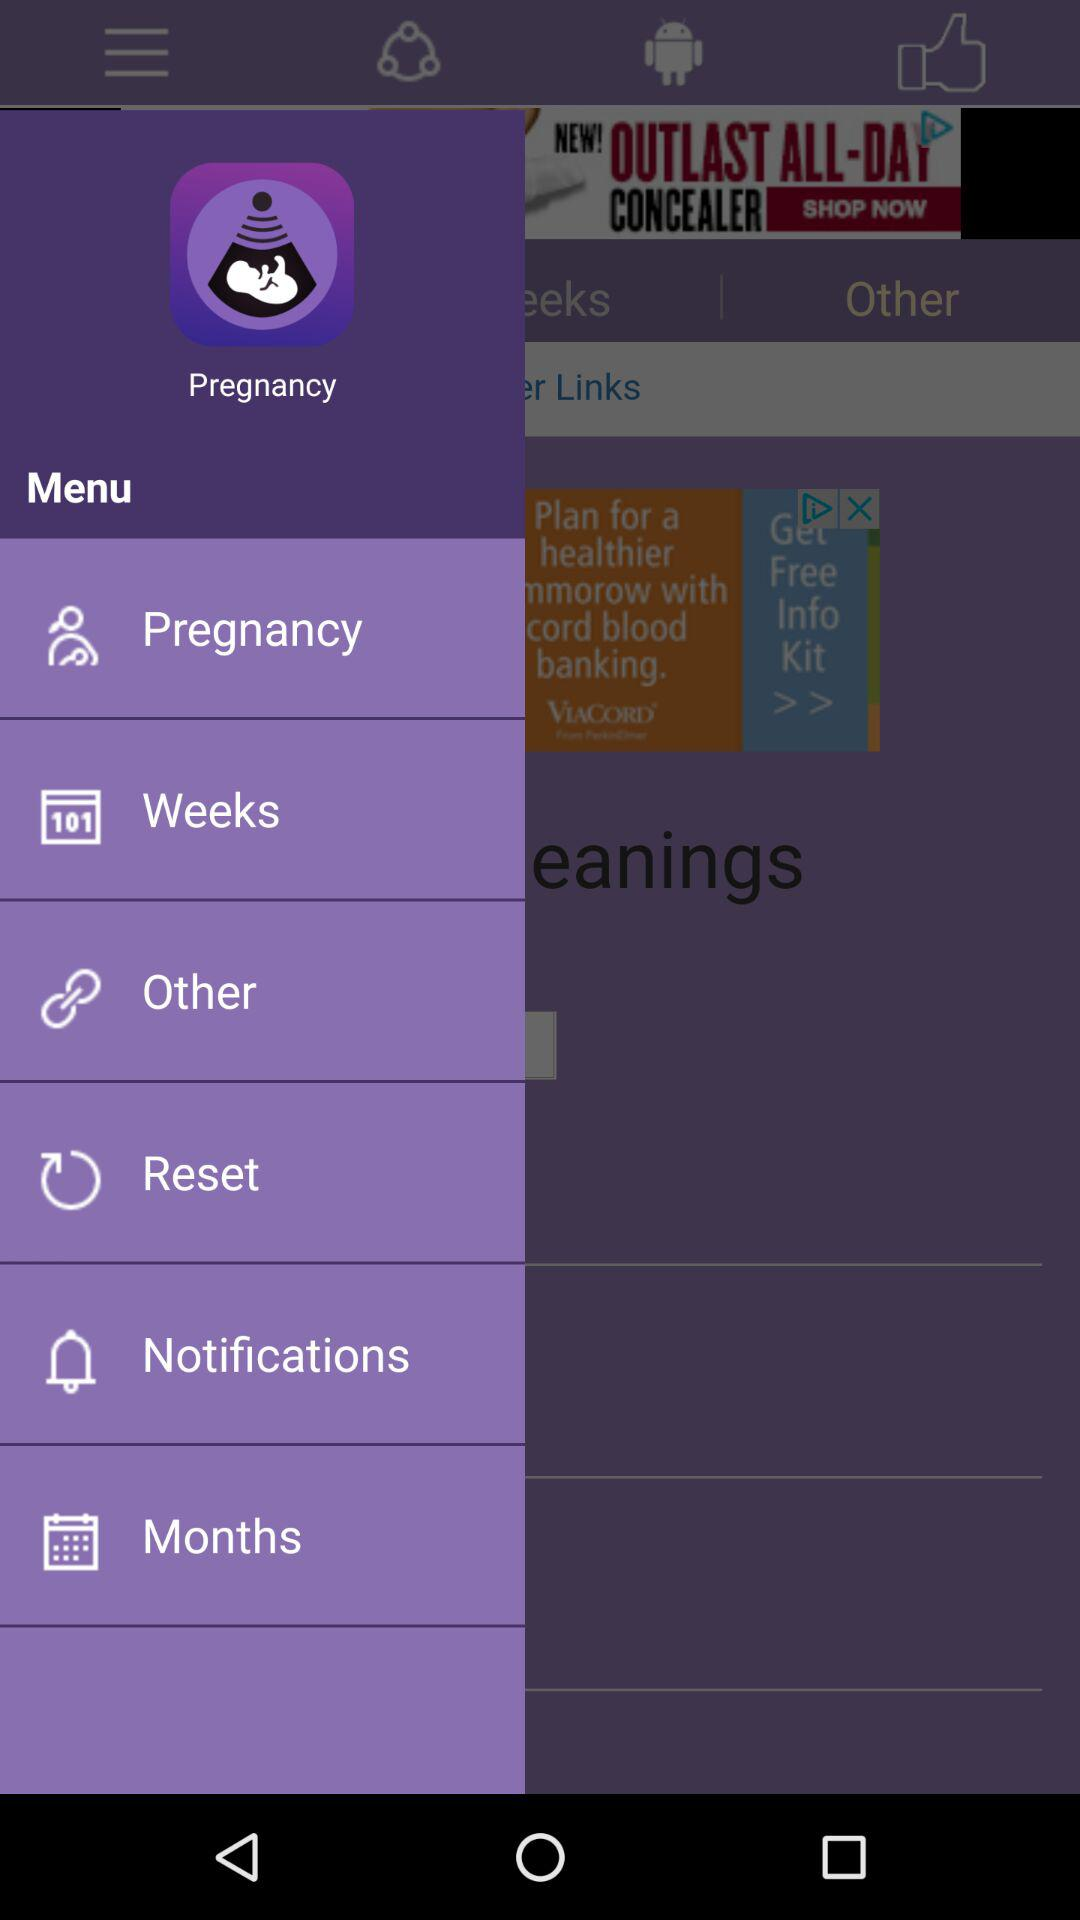What is the name of the application? The name of the application is "Pregnancy Tracker". 